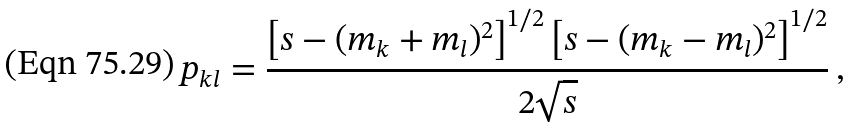<formula> <loc_0><loc_0><loc_500><loc_500>p _ { k l } = \frac { \left [ s - ( m _ { k } + m _ { l } ) ^ { 2 } \right ] ^ { 1 / 2 } \left [ s - ( m _ { k } - m _ { l } ) ^ { 2 } \right ] ^ { 1 / 2 } } { 2 \sqrt { s } } \, ,</formula> 